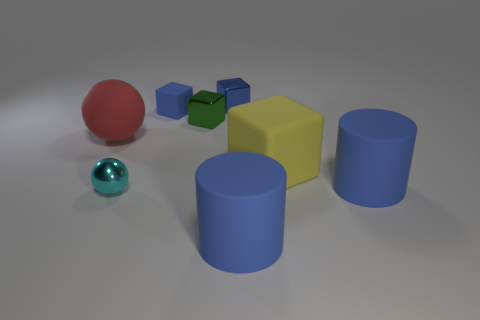There is a yellow object; is its size the same as the matte object that is left of the blue rubber cube? yes 